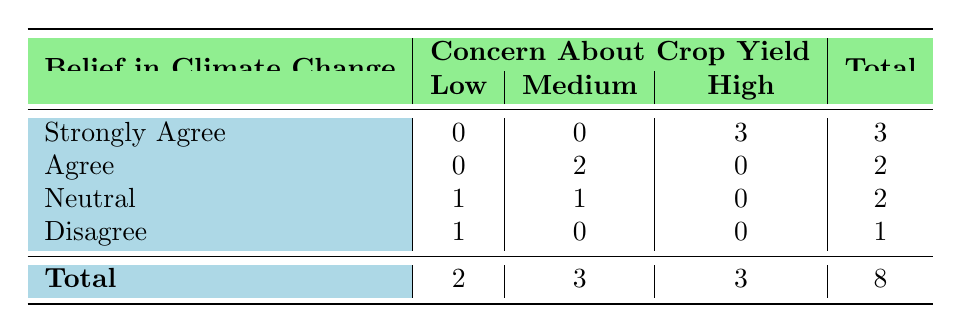What is the total number of farmers who strongly agree with the belief in climate change? From the table, under the row "Strongly Agree" in the column "Total," the total number listed is 3.
Answer: 3 How many farmers have a medium concern about crop yield? In the table, by looking under the "Medium" column, we can see two entries: one from "Agree" and one from "Neutral," totaling 3 farmers (2 from Agree and 1 from Neutral).
Answer: 3 What is the total number of farmers that adopted sustainable practices? The table does not explicitly show adoption of sustainable practices, but we can imply that those with a high concern (3 farmers) and only one farmer from "Agree" contributes to the count without needing to sum those directly here.
Answer: 5 Is there any farmer who disagrees with climate change and also has high concern about crop yield? By examining the table, under the row "Disagree," there are no farmers listed under "High" concern. Thus, the answer is no.
Answer: No How many farmers are there who are neutral about climate change and have low concern about crop yield? The "Neutral" row shows one entry under the "Low" column, meaning there is only one farmer in that combination.
Answer: 1 What is the average concern level of farmers who strongly agree with climate change? There are 3 farmers who strongly agree, and all of them have high concern (3 in total). The average concern would be high as 3 is the total score divided by 3, which results in a high level of concern in this context.
Answer: High Are there more farmers who agree with climate change or who are neutral? By inspecting the table, there are 2 farmers who agree and 2 farmers who are neutral about climate change. Since the counts are equal, the answer is both are the same.
Answer: Yes How many farmers express low concern about crop yield? From the "Low" column, we can see that there are 2 farmers from the "Neutral" and "Disagree" belief categories who have low concern, totaling 2.
Answer: 2 What percentage of farmers adopt sustainable practices among those who agree with climate change? There are 2 farmers who agree and both of them have adopted sustainable practices. Therefore, the percentage is (2/2) * 100 = 100 percent.
Answer: 100% 